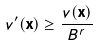<formula> <loc_0><loc_0><loc_500><loc_500>v ^ { \prime } ( { \mathbf x } ) \geq \frac { v ( { \mathbf x } ) } { B ^ { r } }</formula> 